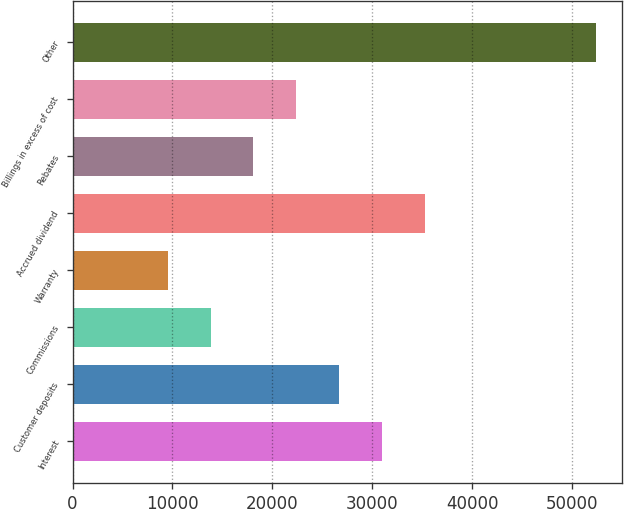Convert chart to OTSL. <chart><loc_0><loc_0><loc_500><loc_500><bar_chart><fcel>Interest<fcel>Customer deposits<fcel>Commissions<fcel>Warranty<fcel>Accrued dividend<fcel>Rebates<fcel>Billings in excess of cost<fcel>Other<nl><fcel>30955.5<fcel>26671.8<fcel>13820.7<fcel>9537<fcel>35239.2<fcel>18104.4<fcel>22388.1<fcel>52374<nl></chart> 